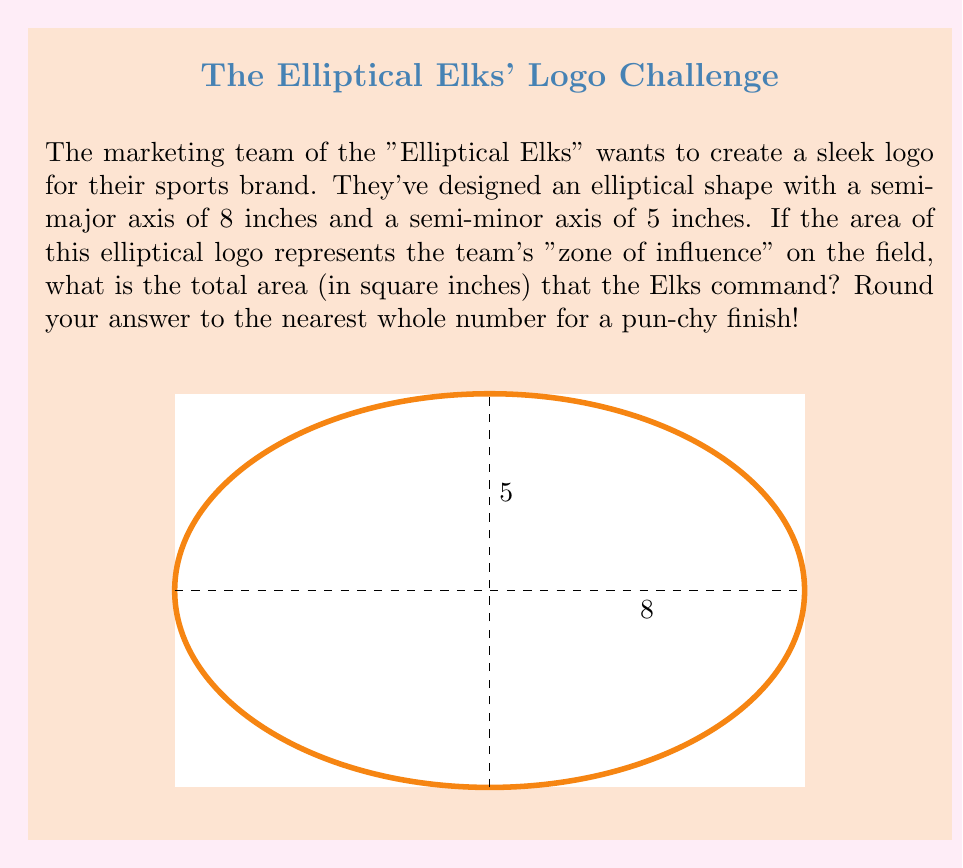Could you help me with this problem? Let's tackle this step-by-step:

1) The formula for the area of an ellipse is:

   $$A = \pi ab$$

   where $a$ is the semi-major axis and $b$ is the semi-minor axis.

2) We're given:
   $a = 8$ inches (semi-major axis)
   $b = 5$ inches (semi-minor axis)

3) Let's substitute these values into our formula:

   $$A = \pi (8)(5)$$

4) Simplify:
   $$A = 40\pi$$

5) Now, let's calculate this:
   $$A \approx 40 \times 3.14159 \approx 125.66356$$

6) Rounding to the nearest whole number as requested:
   $$A \approx 126$$ square inches

So, the Elliptical Elks' "zone of influence" covers approximately 126 square inches. That's quite an "elk-cellent" area for their logo!
Answer: 126 square inches 